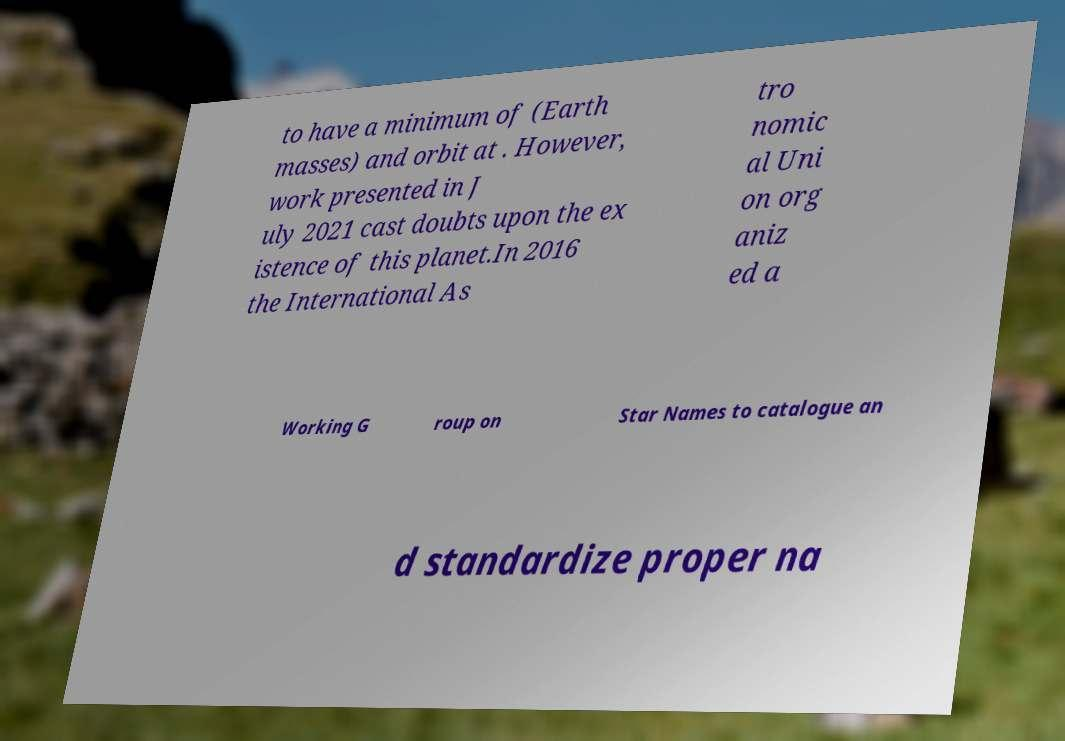Can you accurately transcribe the text from the provided image for me? to have a minimum of (Earth masses) and orbit at . However, work presented in J uly 2021 cast doubts upon the ex istence of this planet.In 2016 the International As tro nomic al Uni on org aniz ed a Working G roup on Star Names to catalogue an d standardize proper na 